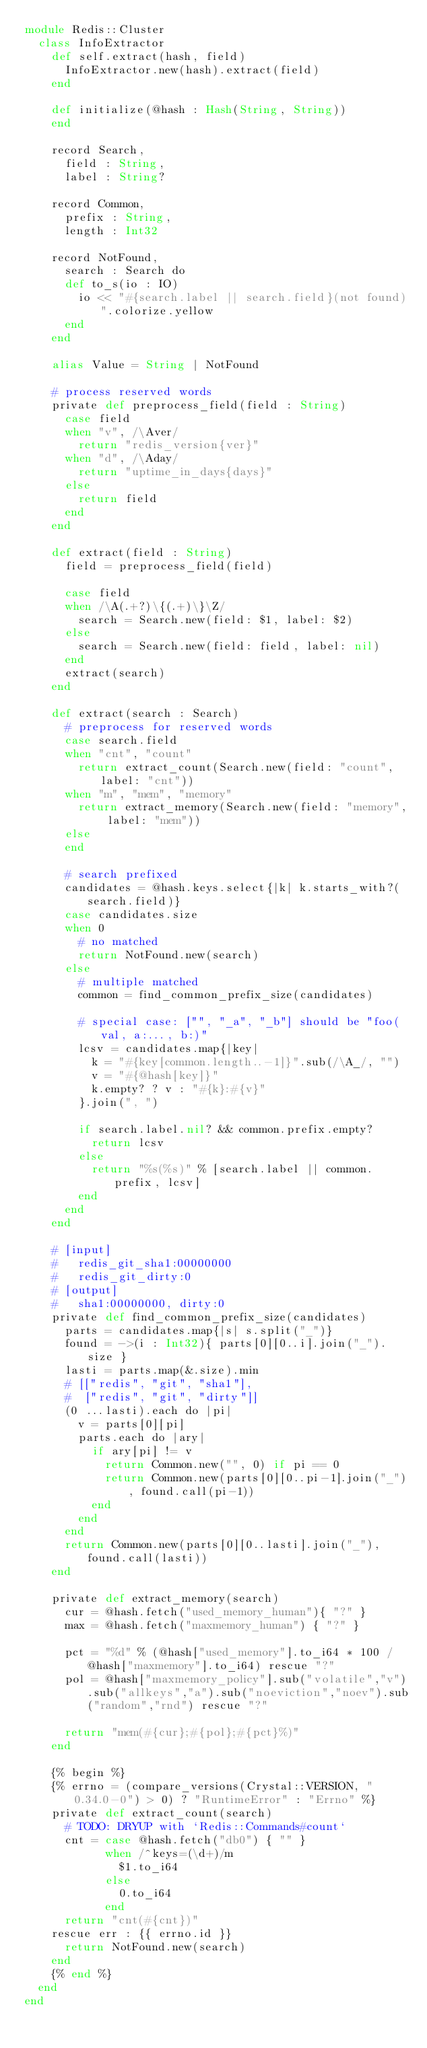<code> <loc_0><loc_0><loc_500><loc_500><_Crystal_>module Redis::Cluster
  class InfoExtractor
    def self.extract(hash, field)
      InfoExtractor.new(hash).extract(field)
    end

    def initialize(@hash : Hash(String, String))
    end

    record Search,
      field : String,
      label : String?
      
    record Common,
      prefix : String,
      length : Int32
      
    record NotFound,
      search : Search do
      def to_s(io : IO)
        io << "#{search.label || search.field}(not found)".colorize.yellow
      end
    end

    alias Value = String | NotFound

    # process reserved words
    private def preprocess_field(field : String)
      case field
      when "v", /\Aver/
        return "redis_version{ver}"
      when "d", /\Aday/
        return "uptime_in_days{days}"
      else
        return field
      end
    end
    
    def extract(field : String)
      field = preprocess_field(field)

      case field
      when /\A(.+?)\{(.+)\}\Z/
        search = Search.new(field: $1, label: $2)
      else
        search = Search.new(field: field, label: nil)
      end
      extract(search)
    end

    def extract(search : Search)
      # preprocess for reserved words
      case search.field
      when "cnt", "count"
        return extract_count(Search.new(field: "count", label: "cnt"))
      when "m", "mem", "memory"
        return extract_memory(Search.new(field: "memory", label: "mem"))
      else
      end
      
      # search prefixed
      candidates = @hash.keys.select{|k| k.starts_with?(search.field)}
      case candidates.size
      when 0 
        # no matched
        return NotFound.new(search)
      else
        # multiple matched
        common = find_common_prefix_size(candidates)

        # special case: ["", "_a", "_b"] should be "foo(val, a:..., b:)"
        lcsv = candidates.map{|key|
          k = "#{key[common.length..-1]}".sub(/\A_/, "")
          v = "#{@hash[key]}"
          k.empty? ? v : "#{k}:#{v}"
        }.join(", ")

        if search.label.nil? && common.prefix.empty?
          return lcsv
        else
          return "%s(%s)" % [search.label || common.prefix, lcsv]
        end
      end
    end

    # [input]
    #   redis_git_sha1:00000000
    #   redis_git_dirty:0
    # [output]
    #   sha1:00000000, dirty:0
    private def find_common_prefix_size(candidates)
      parts = candidates.map{|s| s.split("_")}
      found = ->(i : Int32){ parts[0][0..i].join("_").size }
      lasti = parts.map(&.size).min
      # [["redis", "git", "sha1"],
      #  ["redis", "git", "dirty"]]
      (0 ...lasti).each do |pi|
        v = parts[0][pi]
        parts.each do |ary|
          if ary[pi] != v
            return Common.new("", 0) if pi == 0
            return Common.new(parts[0][0..pi-1].join("_"), found.call(pi-1))
          end
        end
      end
      return Common.new(parts[0][0..lasti].join("_"), found.call(lasti))
    end

    private def extract_memory(search)
      cur = @hash.fetch("used_memory_human"){ "?" }
      max = @hash.fetch("maxmemory_human") { "?" }

      pct = "%d" % (@hash["used_memory"].to_i64 * 100 / @hash["maxmemory"].to_i64) rescue "?"
      pol = @hash["maxmemory_policy"].sub("volatile","v").sub("allkeys","a").sub("noeviction","noev").sub("random","rnd") rescue "?"
        
      return "mem(#{cur};#{pol};#{pct}%)"
    end

    {% begin %}
    {% errno = (compare_versions(Crystal::VERSION, "0.34.0-0") > 0) ? "RuntimeError" : "Errno" %}
    private def extract_count(search)
      # TODO: DRYUP with `Redis::Commands#count`
      cnt = case @hash.fetch("db0") { "" }
            when /^keys=(\d+)/m
              $1.to_i64
            else
              0.to_i64
            end
      return "cnt(#{cnt})"
    rescue err : {{ errno.id }}
      return NotFound.new(search)
    end
    {% end %}
  end
end
</code> 